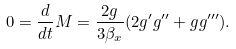Convert formula to latex. <formula><loc_0><loc_0><loc_500><loc_500>0 = \frac { d } { d t } M = \frac { 2 g } { 3 \beta _ { x } } ( 2 g ^ { \prime } g ^ { \prime \prime } + g g ^ { \prime \prime \prime } ) .</formula> 